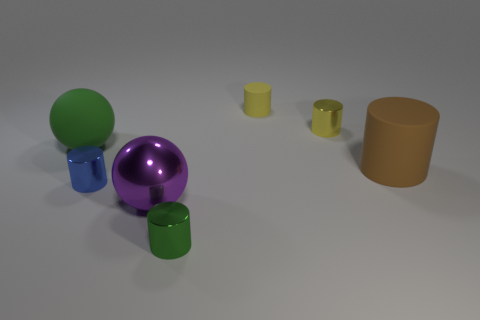Are there any tiny shiny cylinders of the same color as the large shiny object?
Offer a terse response. No. What shape is the yellow object that is the same size as the yellow metallic cylinder?
Offer a very short reply. Cylinder. Are there any brown rubber objects in front of the yellow shiny cylinder?
Provide a succinct answer. Yes. Is the sphere to the right of the small blue cylinder made of the same material as the green thing that is right of the tiny blue metal cylinder?
Offer a terse response. Yes. How many other metallic objects have the same size as the green shiny thing?
Your answer should be compact. 2. There is a tiny thing that is the same color as the tiny rubber cylinder; what shape is it?
Keep it short and to the point. Cylinder. There is a ball on the right side of the green rubber thing; what is its material?
Make the answer very short. Metal. How many shiny objects are the same shape as the green rubber object?
Provide a succinct answer. 1. There is a tiny thing that is the same material as the brown cylinder; what shape is it?
Your answer should be compact. Cylinder. There is a small metal thing behind the rubber thing that is on the left side of the large thing that is in front of the large brown thing; what shape is it?
Provide a short and direct response. Cylinder. 